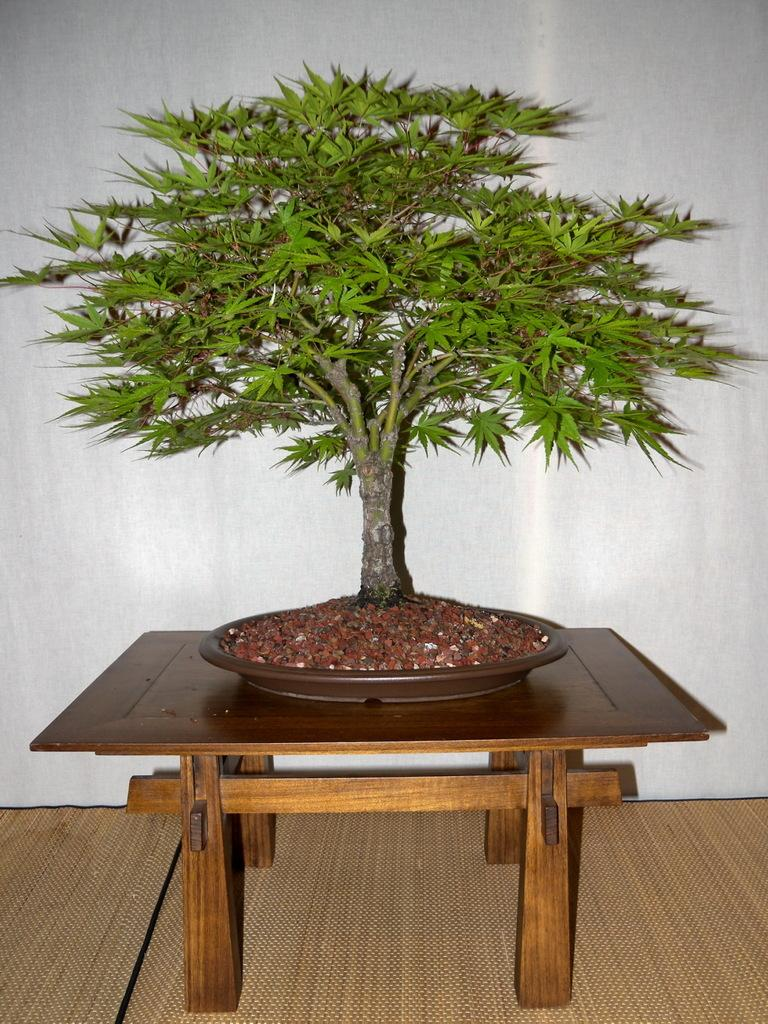What is present in the image? There is a plant in the image. Where is the plant located? The plant is placed on a table. What type of bell can be heard ringing in the image? There is no bell present in the image, and therefore no sound can be heard. 